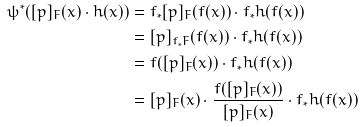Convert formula to latex. <formula><loc_0><loc_0><loc_500><loc_500>\psi ^ { * } ( [ p ] _ { F } ( x ) \cdot h ( x ) ) & = f _ { * } [ p ] _ { F } ( f ( x ) ) \cdot f _ { * } h ( f ( x ) ) \\ & = [ p ] _ { f _ { * } F } ( f ( x ) ) \cdot f _ { * } h ( f ( x ) ) \\ & = f ( [ p ] _ { F } ( x ) ) \cdot f _ { * } h ( f ( x ) ) \\ & = [ p ] _ { F } ( x ) \cdot \frac { f ( [ p ] _ { F } ( x ) ) } { [ p ] _ { F } ( x ) } \cdot f _ { * } h ( f ( x ) )</formula> 